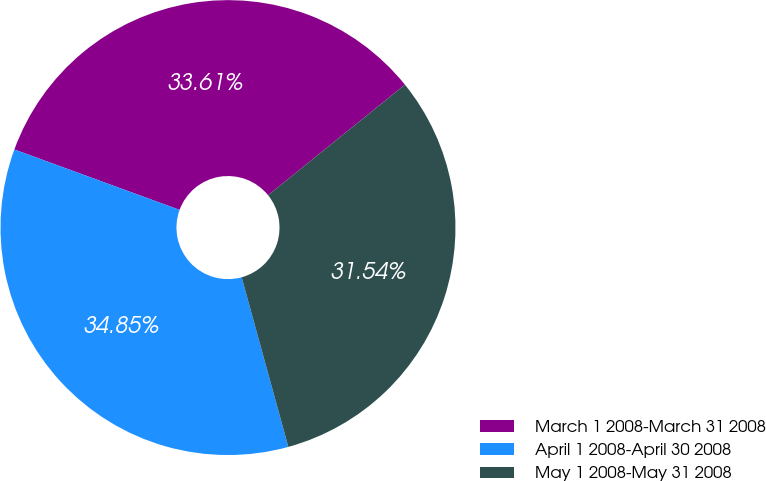<chart> <loc_0><loc_0><loc_500><loc_500><pie_chart><fcel>March 1 2008-March 31 2008<fcel>April 1 2008-April 30 2008<fcel>May 1 2008-May 31 2008<nl><fcel>33.61%<fcel>34.85%<fcel>31.54%<nl></chart> 